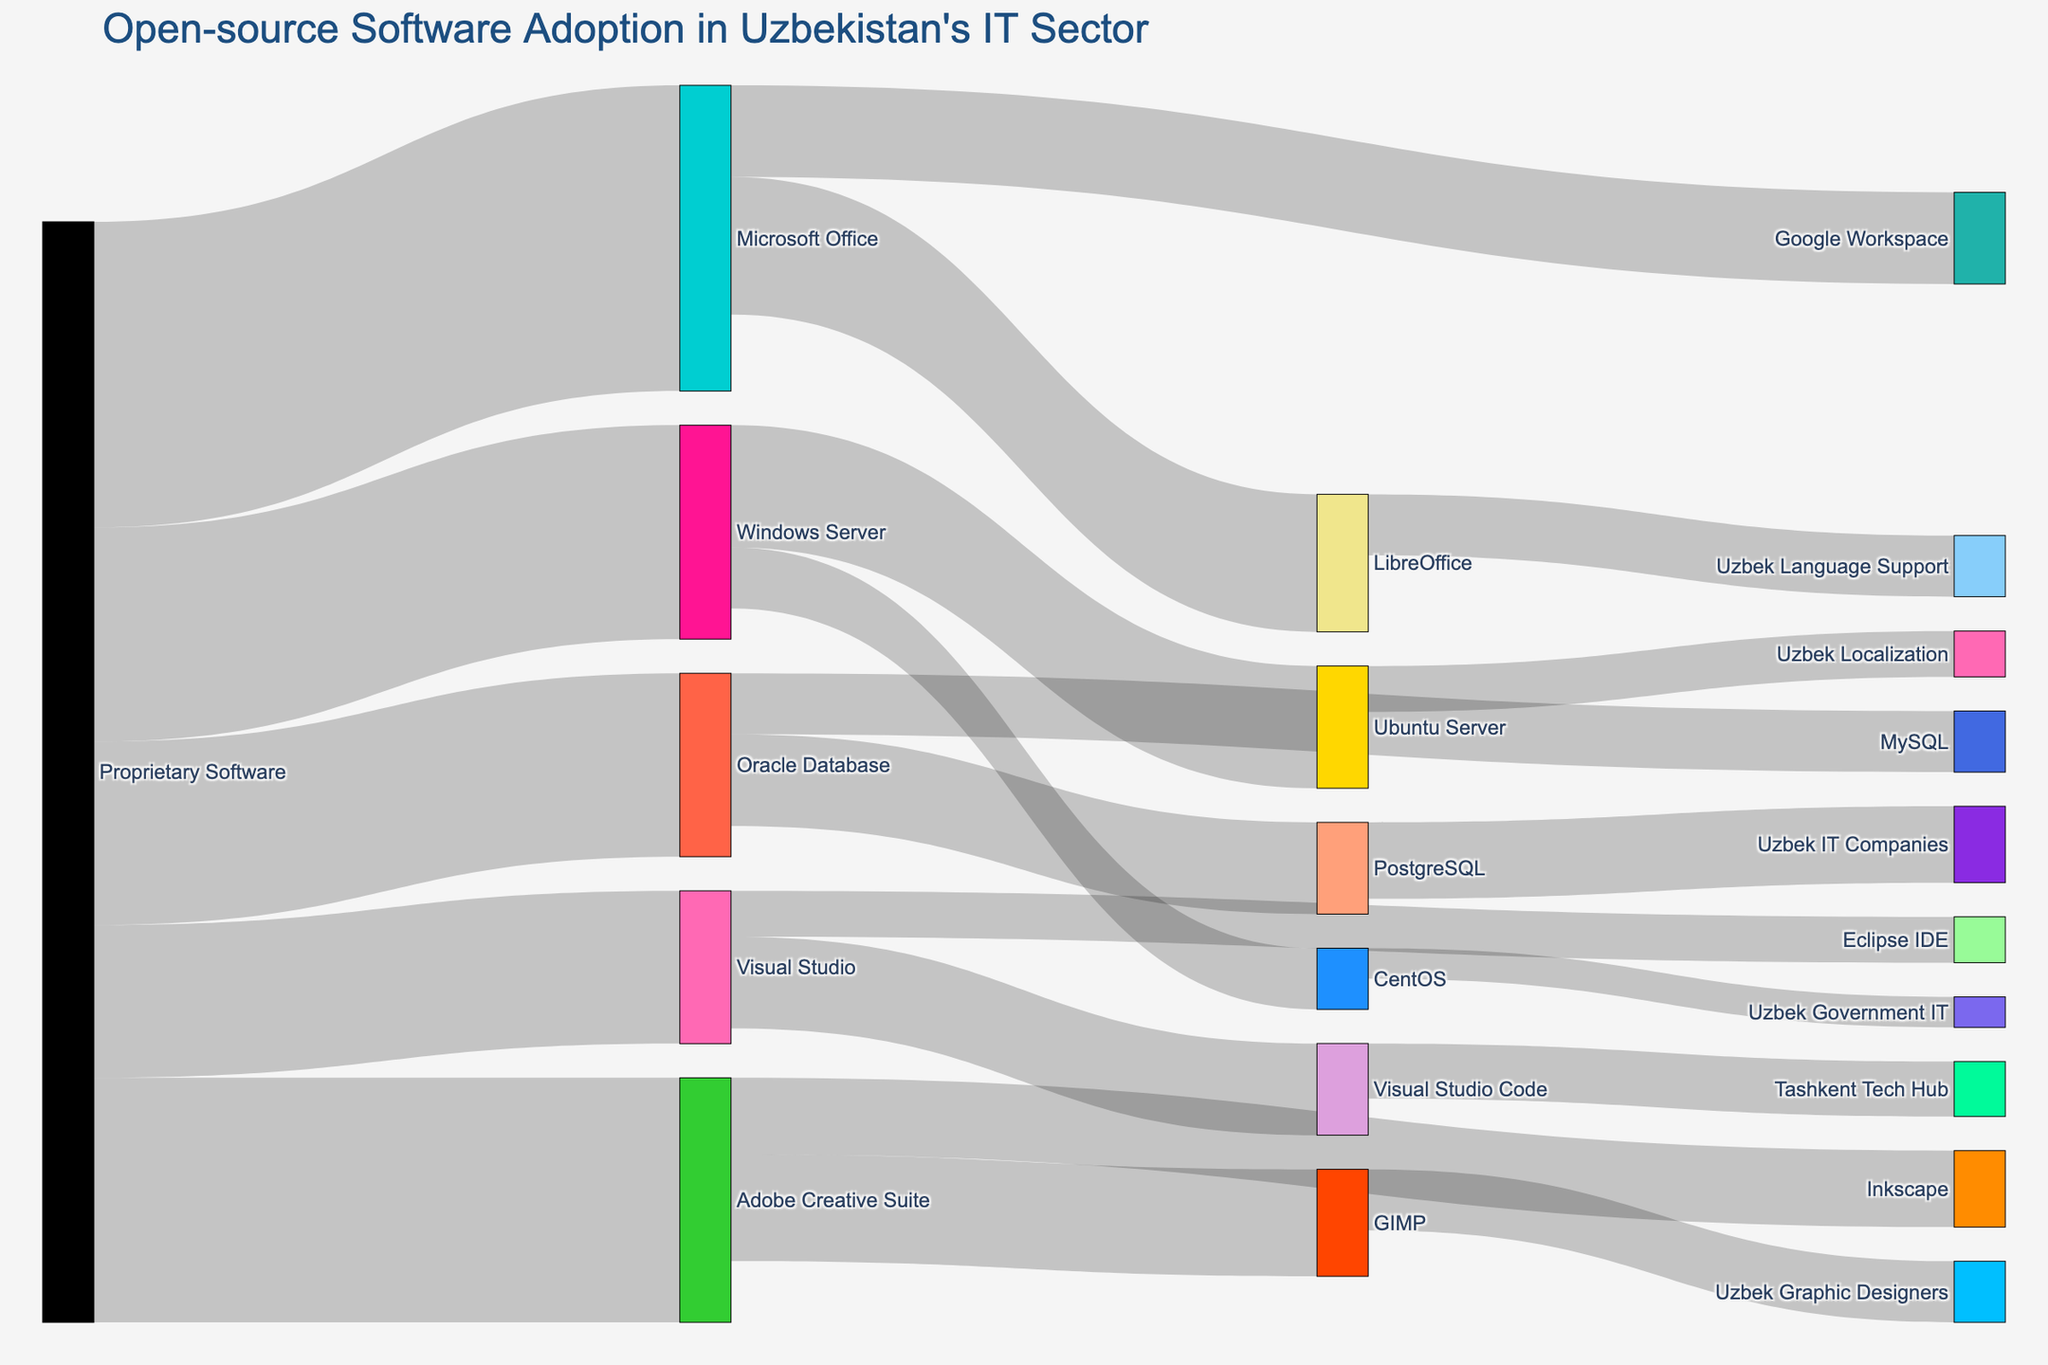What's the title of the figure? The title of the figure is located at the top of the Sankey Diagram and typically provides a summary of the visual information being displayed. In this case, the title reads 'Open-source Software Adoption in Uzbekistan's IT Sector'.
Answer: Open-source Software Adoption in Uzbekistan's IT Sector Which proprietary software has the highest initial value before transitioning to open-source software? To identify which proprietary software has the highest initial value, look for the source node with the largest outgoing value. "Microsoft Office" with a value of 1000 has the highest initial value before transitioning to open-source solutions.
Answer: Microsoft Office How many open-source solutions are being adopted in total? To answer this question, count all unique target nodes in the figure that are open-source solutions. These include LibreOffice, Google Workspace, GIMP, Inkscape, PostgreSQL, MySQL, Ubuntu Server, CentOS, Visual Studio Code, and Eclipse IDE. There are 10 unique open-source solutions in total.
Answer: 10 What is the sum of values transitioning from Oracle Database to open-source solutions? To find the sum of values transitioning from Oracle Database, add the values for PostgreSQL and MySQL. These values are 300 and 200, respectively, so the sum is 300 + 200 = 500.
Answer: 500 Which open-source software receives the largest transition value from proprietary software? Compare the values going from proprietary to open-source software directly. LibreOffice receives 450 from Microsoft Office, the highest transition value among all.
Answer: LibreOffice What is the total value attributed to proprietary software before any transitions? To find the total initial value of proprietary software, sum the values of all initial proprietary software nodes: Microsoft Office (1000), Adobe Creative Suite (800), Oracle Database (600), Windows Server (700), and Visual Studio (500). The sum is 1000 + 800 + 600 + 700 + 500 = 3600.
Answer: 3600 Which transition process involves Uzbek localization or support? Check for target nodes related to the Uzbek language. LibreOffice transitions to Uzbek Language Support with 200, and Ubuntu Server transitions to Uzbek Localization with 150. These two transitions involve Uzbek localization or support.
Answer: LibreOffice to Uzbek Language Support, Ubuntu Server to Uzbek Localization What is the value associated with the transition from LibreOffice to Uzbek Language Support? Locate the node representing the transition from LibreOffice and find the value associated. The value is explicitly shown as 200.
Answer: 200 How does the total value flowing into Ubuntu Server compare to CentOS? Add the incoming values for Ubuntu Server and CentOS and then compare. Ubuntu Server has 400 coming from Windows Server, and CentOS has 200 coming from Windows Server. Therefore, Ubuntu Server has twice the value flowing into it compared to CentOS.
Answer: Ubuntu Server has twice the value compared to CentOS 